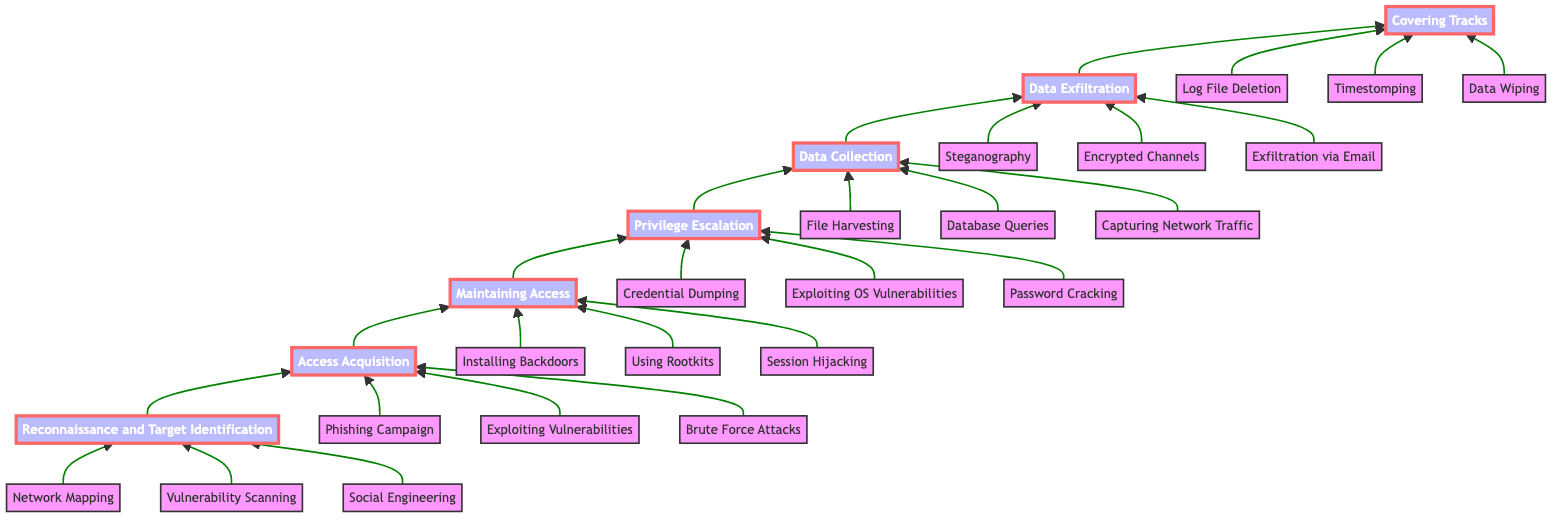What is the first phase in the roadmap? The first phase in the roadmap is at the bottom of the flowchart, labeled "Reconnaissance and Target Identification," which is the starting point of the data exfiltration operations.
Answer: Reconnaissance and Target Identification How many phases are in the roadmap? The flowchart shows a total of seven distinct phases, listed from the bottom to the top, making it easy to count each phase.
Answer: Seven What techniques are employed in the "Access Acquisition" phase? Examining the "Access Acquisition" phase, we can identify three techniques listed directly under it, which are the key methods utilized in this step.
Answer: Phishing Campaign, Exploiting Vulnerabilities, Brute Force Attacks What comes immediately after “Data Collection” in the flowchart? Looking up from the "Data Collection" phase, the next phase indicated by the arrow above it is "Data Exfiltration," showing the direct progression of steps.
Answer: Data Exfiltration Which phase involves "Log File Deletion"? The "Log File Deletion" technique is listed directly under the "Covering Tracks" phase, which focuses on measures taken to erase intrusion traces.
Answer: Covering Tracks What is the relationship between "Privilege Escalation" and "Data Collection"? "Privilege Escalation" precedes "Data Collection" in the flowchart, indicating that obtaining higher-level permissions is a necessary step before collecting sensitive data.
Answer: Privilege Escalation comes before Data Collection How many techniques are listed under "Maintaining Access"? The "Maintaining Access" phase has three techniques listed, providing specific methods for retaining access after a system has been compromised.
Answer: Three Which phase has three techniques related to "capturing network traffic"? The "Data Collection" phase mentions the technique "Capturing Network Traffic" along with others, as this phase is dedicated to gathering sensitive data from the target.
Answer: Data Collection What is the final step in the Data Exfiltration Operations Roadmap? The last phase shown at the top of the flowchart is "Covering Tracks," which is the concluding act after data has been exfiltrated, to prevent detection.
Answer: Covering Tracks 